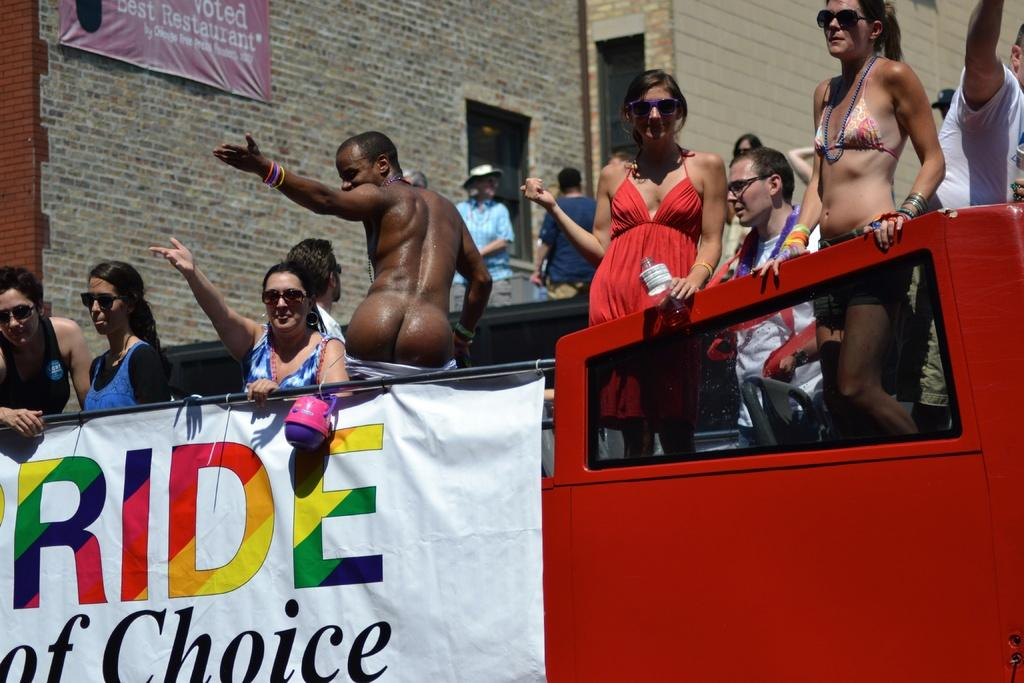Who or what can be seen in the image? There are people in the image. What is hanging in the image? There is a banner in the image. What else can be seen in the image besides people and the banner? There is a vehicle in the image. Can you describe the background of the image? In the background, there are walls, doors, a pole, and another banner. What type of pen is being used to write on the banner in the image? There is no pen visible in the image, and no writing is shown on the banner. 